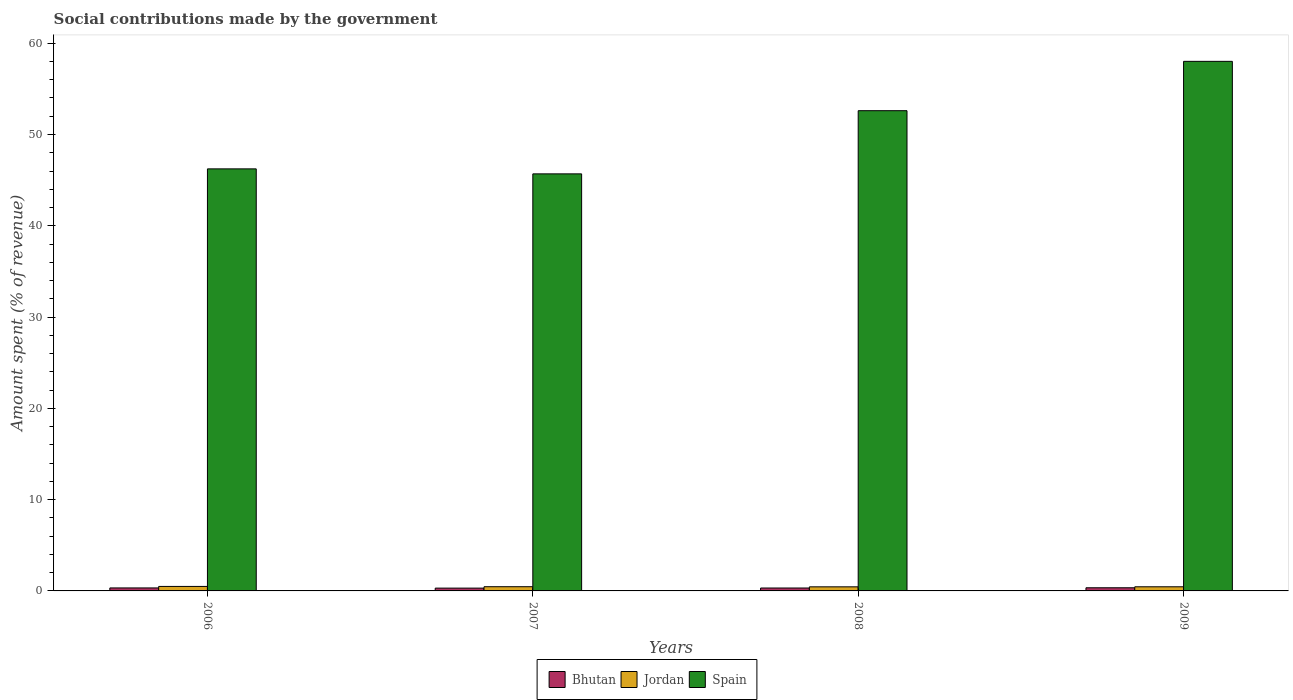How many bars are there on the 4th tick from the left?
Ensure brevity in your answer.  3. How many bars are there on the 4th tick from the right?
Provide a short and direct response. 3. What is the amount spent (in %) on social contributions in Spain in 2006?
Your response must be concise. 46.23. Across all years, what is the maximum amount spent (in %) on social contributions in Bhutan?
Give a very brief answer. 0.35. Across all years, what is the minimum amount spent (in %) on social contributions in Spain?
Make the answer very short. 45.69. In which year was the amount spent (in %) on social contributions in Bhutan minimum?
Your response must be concise. 2007. What is the total amount spent (in %) on social contributions in Bhutan in the graph?
Ensure brevity in your answer.  1.3. What is the difference between the amount spent (in %) on social contributions in Spain in 2006 and that in 2008?
Your answer should be very brief. -6.37. What is the difference between the amount spent (in %) on social contributions in Spain in 2008 and the amount spent (in %) on social contributions in Jordan in 2006?
Offer a terse response. 52.12. What is the average amount spent (in %) on social contributions in Spain per year?
Make the answer very short. 50.64. In the year 2009, what is the difference between the amount spent (in %) on social contributions in Spain and amount spent (in %) on social contributions in Jordan?
Give a very brief answer. 57.56. In how many years, is the amount spent (in %) on social contributions in Jordan greater than 46 %?
Provide a short and direct response. 0. What is the ratio of the amount spent (in %) on social contributions in Spain in 2007 to that in 2008?
Provide a short and direct response. 0.87. Is the amount spent (in %) on social contributions in Jordan in 2006 less than that in 2009?
Your answer should be very brief. No. What is the difference between the highest and the second highest amount spent (in %) on social contributions in Bhutan?
Ensure brevity in your answer.  0.02. What is the difference between the highest and the lowest amount spent (in %) on social contributions in Spain?
Give a very brief answer. 12.33. Is the sum of the amount spent (in %) on social contributions in Bhutan in 2006 and 2009 greater than the maximum amount spent (in %) on social contributions in Jordan across all years?
Make the answer very short. Yes. Is it the case that in every year, the sum of the amount spent (in %) on social contributions in Bhutan and amount spent (in %) on social contributions in Jordan is greater than the amount spent (in %) on social contributions in Spain?
Provide a succinct answer. No. How many bars are there?
Keep it short and to the point. 12. How many years are there in the graph?
Offer a terse response. 4. Are the values on the major ticks of Y-axis written in scientific E-notation?
Provide a short and direct response. No. Does the graph contain any zero values?
Keep it short and to the point. No. Does the graph contain grids?
Provide a succinct answer. No. How many legend labels are there?
Your answer should be compact. 3. How are the legend labels stacked?
Provide a succinct answer. Horizontal. What is the title of the graph?
Your response must be concise. Social contributions made by the government. What is the label or title of the Y-axis?
Give a very brief answer. Amount spent (% of revenue). What is the Amount spent (% of revenue) of Bhutan in 2006?
Ensure brevity in your answer.  0.33. What is the Amount spent (% of revenue) of Jordan in 2006?
Offer a terse response. 0.49. What is the Amount spent (% of revenue) of Spain in 2006?
Make the answer very short. 46.23. What is the Amount spent (% of revenue) in Bhutan in 2007?
Provide a succinct answer. 0.31. What is the Amount spent (% of revenue) of Jordan in 2007?
Your response must be concise. 0.46. What is the Amount spent (% of revenue) in Spain in 2007?
Provide a short and direct response. 45.69. What is the Amount spent (% of revenue) in Bhutan in 2008?
Ensure brevity in your answer.  0.32. What is the Amount spent (% of revenue) in Jordan in 2008?
Keep it short and to the point. 0.45. What is the Amount spent (% of revenue) in Spain in 2008?
Your answer should be very brief. 52.61. What is the Amount spent (% of revenue) of Bhutan in 2009?
Your answer should be very brief. 0.35. What is the Amount spent (% of revenue) in Jordan in 2009?
Offer a very short reply. 0.45. What is the Amount spent (% of revenue) of Spain in 2009?
Provide a succinct answer. 58.01. Across all years, what is the maximum Amount spent (% of revenue) of Bhutan?
Offer a terse response. 0.35. Across all years, what is the maximum Amount spent (% of revenue) of Jordan?
Your response must be concise. 0.49. Across all years, what is the maximum Amount spent (% of revenue) of Spain?
Give a very brief answer. 58.01. Across all years, what is the minimum Amount spent (% of revenue) of Bhutan?
Ensure brevity in your answer.  0.31. Across all years, what is the minimum Amount spent (% of revenue) of Jordan?
Offer a very short reply. 0.45. Across all years, what is the minimum Amount spent (% of revenue) in Spain?
Your response must be concise. 45.69. What is the total Amount spent (% of revenue) in Bhutan in the graph?
Provide a short and direct response. 1.3. What is the total Amount spent (% of revenue) in Jordan in the graph?
Offer a very short reply. 1.85. What is the total Amount spent (% of revenue) in Spain in the graph?
Make the answer very short. 202.54. What is the difference between the Amount spent (% of revenue) of Bhutan in 2006 and that in 2007?
Ensure brevity in your answer.  0.02. What is the difference between the Amount spent (% of revenue) in Jordan in 2006 and that in 2007?
Keep it short and to the point. 0.03. What is the difference between the Amount spent (% of revenue) of Spain in 2006 and that in 2007?
Provide a succinct answer. 0.55. What is the difference between the Amount spent (% of revenue) in Bhutan in 2006 and that in 2008?
Provide a short and direct response. 0.01. What is the difference between the Amount spent (% of revenue) of Jordan in 2006 and that in 2008?
Your response must be concise. 0.04. What is the difference between the Amount spent (% of revenue) in Spain in 2006 and that in 2008?
Make the answer very short. -6.37. What is the difference between the Amount spent (% of revenue) of Bhutan in 2006 and that in 2009?
Provide a short and direct response. -0.02. What is the difference between the Amount spent (% of revenue) in Jordan in 2006 and that in 2009?
Your answer should be compact. 0.04. What is the difference between the Amount spent (% of revenue) in Spain in 2006 and that in 2009?
Provide a short and direct response. -11.78. What is the difference between the Amount spent (% of revenue) of Bhutan in 2007 and that in 2008?
Your answer should be very brief. -0.01. What is the difference between the Amount spent (% of revenue) of Jordan in 2007 and that in 2008?
Your response must be concise. 0.01. What is the difference between the Amount spent (% of revenue) of Spain in 2007 and that in 2008?
Make the answer very short. -6.92. What is the difference between the Amount spent (% of revenue) in Bhutan in 2007 and that in 2009?
Provide a short and direct response. -0.04. What is the difference between the Amount spent (% of revenue) in Jordan in 2007 and that in 2009?
Make the answer very short. 0.01. What is the difference between the Amount spent (% of revenue) of Spain in 2007 and that in 2009?
Offer a terse response. -12.33. What is the difference between the Amount spent (% of revenue) in Bhutan in 2008 and that in 2009?
Ensure brevity in your answer.  -0.03. What is the difference between the Amount spent (% of revenue) in Jordan in 2008 and that in 2009?
Your response must be concise. -0.01. What is the difference between the Amount spent (% of revenue) in Spain in 2008 and that in 2009?
Provide a short and direct response. -5.4. What is the difference between the Amount spent (% of revenue) in Bhutan in 2006 and the Amount spent (% of revenue) in Jordan in 2007?
Ensure brevity in your answer.  -0.13. What is the difference between the Amount spent (% of revenue) of Bhutan in 2006 and the Amount spent (% of revenue) of Spain in 2007?
Ensure brevity in your answer.  -45.36. What is the difference between the Amount spent (% of revenue) in Jordan in 2006 and the Amount spent (% of revenue) in Spain in 2007?
Your response must be concise. -45.19. What is the difference between the Amount spent (% of revenue) in Bhutan in 2006 and the Amount spent (% of revenue) in Jordan in 2008?
Your answer should be very brief. -0.12. What is the difference between the Amount spent (% of revenue) in Bhutan in 2006 and the Amount spent (% of revenue) in Spain in 2008?
Offer a terse response. -52.28. What is the difference between the Amount spent (% of revenue) in Jordan in 2006 and the Amount spent (% of revenue) in Spain in 2008?
Give a very brief answer. -52.12. What is the difference between the Amount spent (% of revenue) in Bhutan in 2006 and the Amount spent (% of revenue) in Jordan in 2009?
Ensure brevity in your answer.  -0.13. What is the difference between the Amount spent (% of revenue) of Bhutan in 2006 and the Amount spent (% of revenue) of Spain in 2009?
Offer a very short reply. -57.68. What is the difference between the Amount spent (% of revenue) in Jordan in 2006 and the Amount spent (% of revenue) in Spain in 2009?
Ensure brevity in your answer.  -57.52. What is the difference between the Amount spent (% of revenue) in Bhutan in 2007 and the Amount spent (% of revenue) in Jordan in 2008?
Offer a terse response. -0.14. What is the difference between the Amount spent (% of revenue) in Bhutan in 2007 and the Amount spent (% of revenue) in Spain in 2008?
Your response must be concise. -52.3. What is the difference between the Amount spent (% of revenue) in Jordan in 2007 and the Amount spent (% of revenue) in Spain in 2008?
Your response must be concise. -52.15. What is the difference between the Amount spent (% of revenue) of Bhutan in 2007 and the Amount spent (% of revenue) of Jordan in 2009?
Ensure brevity in your answer.  -0.15. What is the difference between the Amount spent (% of revenue) of Bhutan in 2007 and the Amount spent (% of revenue) of Spain in 2009?
Offer a very short reply. -57.7. What is the difference between the Amount spent (% of revenue) of Jordan in 2007 and the Amount spent (% of revenue) of Spain in 2009?
Your answer should be compact. -57.55. What is the difference between the Amount spent (% of revenue) in Bhutan in 2008 and the Amount spent (% of revenue) in Jordan in 2009?
Make the answer very short. -0.14. What is the difference between the Amount spent (% of revenue) in Bhutan in 2008 and the Amount spent (% of revenue) in Spain in 2009?
Provide a succinct answer. -57.69. What is the difference between the Amount spent (% of revenue) of Jordan in 2008 and the Amount spent (% of revenue) of Spain in 2009?
Make the answer very short. -57.56. What is the average Amount spent (% of revenue) in Bhutan per year?
Make the answer very short. 0.32. What is the average Amount spent (% of revenue) of Jordan per year?
Ensure brevity in your answer.  0.46. What is the average Amount spent (% of revenue) of Spain per year?
Provide a succinct answer. 50.64. In the year 2006, what is the difference between the Amount spent (% of revenue) of Bhutan and Amount spent (% of revenue) of Jordan?
Provide a short and direct response. -0.16. In the year 2006, what is the difference between the Amount spent (% of revenue) of Bhutan and Amount spent (% of revenue) of Spain?
Give a very brief answer. -45.91. In the year 2006, what is the difference between the Amount spent (% of revenue) in Jordan and Amount spent (% of revenue) in Spain?
Offer a terse response. -45.74. In the year 2007, what is the difference between the Amount spent (% of revenue) of Bhutan and Amount spent (% of revenue) of Jordan?
Your response must be concise. -0.15. In the year 2007, what is the difference between the Amount spent (% of revenue) of Bhutan and Amount spent (% of revenue) of Spain?
Offer a terse response. -45.38. In the year 2007, what is the difference between the Amount spent (% of revenue) of Jordan and Amount spent (% of revenue) of Spain?
Provide a short and direct response. -45.23. In the year 2008, what is the difference between the Amount spent (% of revenue) of Bhutan and Amount spent (% of revenue) of Jordan?
Provide a short and direct response. -0.13. In the year 2008, what is the difference between the Amount spent (% of revenue) in Bhutan and Amount spent (% of revenue) in Spain?
Your response must be concise. -52.29. In the year 2008, what is the difference between the Amount spent (% of revenue) in Jordan and Amount spent (% of revenue) in Spain?
Make the answer very short. -52.16. In the year 2009, what is the difference between the Amount spent (% of revenue) of Bhutan and Amount spent (% of revenue) of Jordan?
Your answer should be compact. -0.11. In the year 2009, what is the difference between the Amount spent (% of revenue) in Bhutan and Amount spent (% of revenue) in Spain?
Ensure brevity in your answer.  -57.67. In the year 2009, what is the difference between the Amount spent (% of revenue) of Jordan and Amount spent (% of revenue) of Spain?
Your answer should be very brief. -57.56. What is the ratio of the Amount spent (% of revenue) in Bhutan in 2006 to that in 2007?
Give a very brief answer. 1.07. What is the ratio of the Amount spent (% of revenue) in Jordan in 2006 to that in 2007?
Keep it short and to the point. 1.07. What is the ratio of the Amount spent (% of revenue) in Spain in 2006 to that in 2007?
Provide a short and direct response. 1.01. What is the ratio of the Amount spent (% of revenue) of Bhutan in 2006 to that in 2008?
Your answer should be compact. 1.03. What is the ratio of the Amount spent (% of revenue) of Jordan in 2006 to that in 2008?
Provide a short and direct response. 1.1. What is the ratio of the Amount spent (% of revenue) in Spain in 2006 to that in 2008?
Keep it short and to the point. 0.88. What is the ratio of the Amount spent (% of revenue) of Bhutan in 2006 to that in 2009?
Provide a succinct answer. 0.95. What is the ratio of the Amount spent (% of revenue) of Jordan in 2006 to that in 2009?
Ensure brevity in your answer.  1.09. What is the ratio of the Amount spent (% of revenue) in Spain in 2006 to that in 2009?
Your answer should be very brief. 0.8. What is the ratio of the Amount spent (% of revenue) of Bhutan in 2007 to that in 2008?
Offer a very short reply. 0.97. What is the ratio of the Amount spent (% of revenue) in Jordan in 2007 to that in 2008?
Keep it short and to the point. 1.03. What is the ratio of the Amount spent (% of revenue) in Spain in 2007 to that in 2008?
Provide a succinct answer. 0.87. What is the ratio of the Amount spent (% of revenue) of Bhutan in 2007 to that in 2009?
Provide a short and direct response. 0.89. What is the ratio of the Amount spent (% of revenue) in Jordan in 2007 to that in 2009?
Provide a short and direct response. 1.02. What is the ratio of the Amount spent (% of revenue) of Spain in 2007 to that in 2009?
Your answer should be compact. 0.79. What is the ratio of the Amount spent (% of revenue) in Bhutan in 2008 to that in 2009?
Offer a very short reply. 0.92. What is the ratio of the Amount spent (% of revenue) in Jordan in 2008 to that in 2009?
Offer a terse response. 0.99. What is the ratio of the Amount spent (% of revenue) in Spain in 2008 to that in 2009?
Provide a succinct answer. 0.91. What is the difference between the highest and the second highest Amount spent (% of revenue) in Bhutan?
Your answer should be very brief. 0.02. What is the difference between the highest and the second highest Amount spent (% of revenue) in Jordan?
Offer a terse response. 0.03. What is the difference between the highest and the second highest Amount spent (% of revenue) in Spain?
Offer a terse response. 5.4. What is the difference between the highest and the lowest Amount spent (% of revenue) of Bhutan?
Your response must be concise. 0.04. What is the difference between the highest and the lowest Amount spent (% of revenue) of Jordan?
Give a very brief answer. 0.04. What is the difference between the highest and the lowest Amount spent (% of revenue) of Spain?
Your response must be concise. 12.33. 